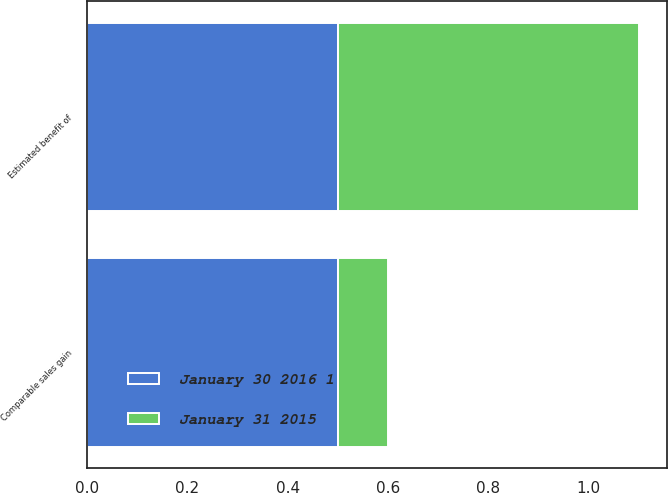<chart> <loc_0><loc_0><loc_500><loc_500><stacked_bar_chart><ecel><fcel>Comparable sales gain<fcel>Estimated benefit of<nl><fcel>January 31 2015<fcel>0.1<fcel>0.6<nl><fcel>January 30 2016 1<fcel>0.5<fcel>0.5<nl></chart> 